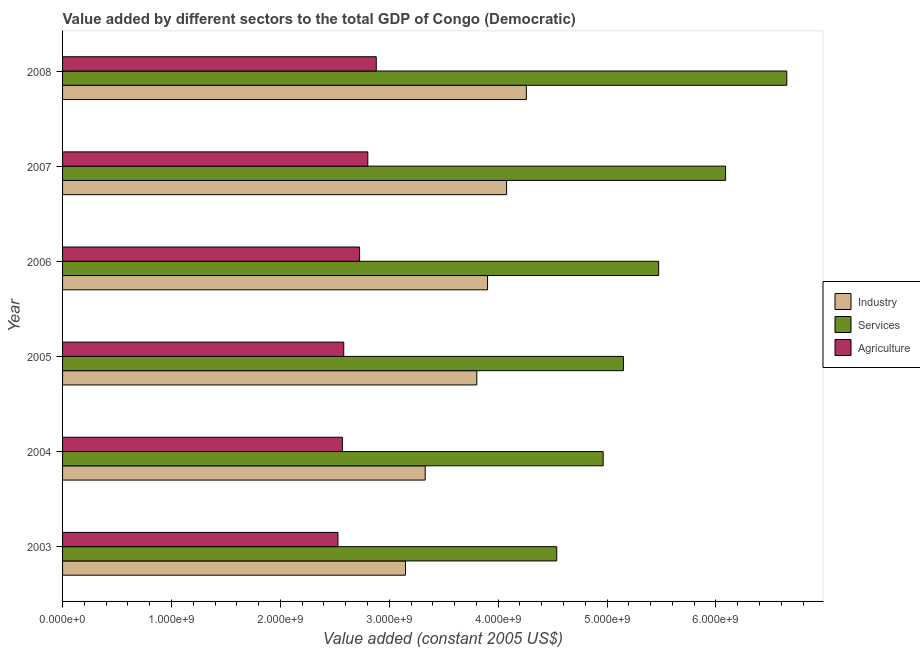Are the number of bars per tick equal to the number of legend labels?
Give a very brief answer. Yes. What is the label of the 4th group of bars from the top?
Provide a succinct answer. 2005. In how many cases, is the number of bars for a given year not equal to the number of legend labels?
Your response must be concise. 0. What is the value added by services in 2005?
Provide a succinct answer. 5.15e+09. Across all years, what is the maximum value added by services?
Provide a short and direct response. 6.65e+09. Across all years, what is the minimum value added by industrial sector?
Your answer should be very brief. 3.15e+09. In which year was the value added by agricultural sector maximum?
Make the answer very short. 2008. In which year was the value added by industrial sector minimum?
Offer a terse response. 2003. What is the total value added by services in the graph?
Offer a terse response. 3.29e+1. What is the difference between the value added by services in 2004 and that in 2007?
Your response must be concise. -1.12e+09. What is the difference between the value added by agricultural sector in 2008 and the value added by industrial sector in 2004?
Your answer should be compact. -4.49e+08. What is the average value added by industrial sector per year?
Your response must be concise. 3.75e+09. In the year 2005, what is the difference between the value added by services and value added by industrial sector?
Provide a short and direct response. 1.35e+09. What is the difference between the highest and the second highest value added by services?
Make the answer very short. 5.62e+08. What is the difference between the highest and the lowest value added by agricultural sector?
Offer a very short reply. 3.52e+08. What does the 3rd bar from the top in 2005 represents?
Your answer should be very brief. Industry. What does the 1st bar from the bottom in 2003 represents?
Give a very brief answer. Industry. Is it the case that in every year, the sum of the value added by industrial sector and value added by services is greater than the value added by agricultural sector?
Provide a short and direct response. Yes. How many years are there in the graph?
Your answer should be compact. 6. Does the graph contain any zero values?
Your answer should be very brief. No. Where does the legend appear in the graph?
Keep it short and to the point. Center right. What is the title of the graph?
Keep it short and to the point. Value added by different sectors to the total GDP of Congo (Democratic). Does "Secondary" appear as one of the legend labels in the graph?
Your answer should be compact. No. What is the label or title of the X-axis?
Offer a very short reply. Value added (constant 2005 US$). What is the label or title of the Y-axis?
Your response must be concise. Year. What is the Value added (constant 2005 US$) of Industry in 2003?
Give a very brief answer. 3.15e+09. What is the Value added (constant 2005 US$) of Services in 2003?
Offer a very short reply. 4.54e+09. What is the Value added (constant 2005 US$) in Agriculture in 2003?
Ensure brevity in your answer.  2.53e+09. What is the Value added (constant 2005 US$) of Industry in 2004?
Your answer should be very brief. 3.33e+09. What is the Value added (constant 2005 US$) in Services in 2004?
Offer a very short reply. 4.96e+09. What is the Value added (constant 2005 US$) in Agriculture in 2004?
Provide a succinct answer. 2.57e+09. What is the Value added (constant 2005 US$) of Industry in 2005?
Provide a short and direct response. 3.80e+09. What is the Value added (constant 2005 US$) in Services in 2005?
Your answer should be compact. 5.15e+09. What is the Value added (constant 2005 US$) of Agriculture in 2005?
Make the answer very short. 2.58e+09. What is the Value added (constant 2005 US$) of Industry in 2006?
Your response must be concise. 3.90e+09. What is the Value added (constant 2005 US$) of Services in 2006?
Offer a terse response. 5.47e+09. What is the Value added (constant 2005 US$) of Agriculture in 2006?
Ensure brevity in your answer.  2.73e+09. What is the Value added (constant 2005 US$) in Industry in 2007?
Ensure brevity in your answer.  4.08e+09. What is the Value added (constant 2005 US$) of Services in 2007?
Provide a short and direct response. 6.09e+09. What is the Value added (constant 2005 US$) of Agriculture in 2007?
Offer a terse response. 2.80e+09. What is the Value added (constant 2005 US$) in Industry in 2008?
Your answer should be compact. 4.26e+09. What is the Value added (constant 2005 US$) of Services in 2008?
Your answer should be very brief. 6.65e+09. What is the Value added (constant 2005 US$) of Agriculture in 2008?
Offer a very short reply. 2.88e+09. Across all years, what is the maximum Value added (constant 2005 US$) in Industry?
Keep it short and to the point. 4.26e+09. Across all years, what is the maximum Value added (constant 2005 US$) of Services?
Your answer should be compact. 6.65e+09. Across all years, what is the maximum Value added (constant 2005 US$) in Agriculture?
Your answer should be very brief. 2.88e+09. Across all years, what is the minimum Value added (constant 2005 US$) in Industry?
Your answer should be compact. 3.15e+09. Across all years, what is the minimum Value added (constant 2005 US$) in Services?
Ensure brevity in your answer.  4.54e+09. Across all years, what is the minimum Value added (constant 2005 US$) of Agriculture?
Make the answer very short. 2.53e+09. What is the total Value added (constant 2005 US$) of Industry in the graph?
Give a very brief answer. 2.25e+1. What is the total Value added (constant 2005 US$) of Services in the graph?
Your answer should be very brief. 3.29e+1. What is the total Value added (constant 2005 US$) in Agriculture in the graph?
Your answer should be compact. 1.61e+1. What is the difference between the Value added (constant 2005 US$) of Industry in 2003 and that in 2004?
Provide a succinct answer. -1.81e+08. What is the difference between the Value added (constant 2005 US$) of Services in 2003 and that in 2004?
Your response must be concise. -4.26e+08. What is the difference between the Value added (constant 2005 US$) of Agriculture in 2003 and that in 2004?
Give a very brief answer. -4.07e+07. What is the difference between the Value added (constant 2005 US$) in Industry in 2003 and that in 2005?
Provide a short and direct response. -6.55e+08. What is the difference between the Value added (constant 2005 US$) of Services in 2003 and that in 2005?
Provide a short and direct response. -6.12e+08. What is the difference between the Value added (constant 2005 US$) of Agriculture in 2003 and that in 2005?
Ensure brevity in your answer.  -5.32e+07. What is the difference between the Value added (constant 2005 US$) in Industry in 2003 and that in 2006?
Ensure brevity in your answer.  -7.54e+08. What is the difference between the Value added (constant 2005 US$) in Services in 2003 and that in 2006?
Ensure brevity in your answer.  -9.36e+08. What is the difference between the Value added (constant 2005 US$) of Agriculture in 2003 and that in 2006?
Offer a terse response. -1.99e+08. What is the difference between the Value added (constant 2005 US$) in Industry in 2003 and that in 2007?
Offer a terse response. -9.29e+08. What is the difference between the Value added (constant 2005 US$) in Services in 2003 and that in 2007?
Your answer should be compact. -1.55e+09. What is the difference between the Value added (constant 2005 US$) of Agriculture in 2003 and that in 2007?
Your response must be concise. -2.74e+08. What is the difference between the Value added (constant 2005 US$) of Industry in 2003 and that in 2008?
Give a very brief answer. -1.11e+09. What is the difference between the Value added (constant 2005 US$) of Services in 2003 and that in 2008?
Your answer should be compact. -2.11e+09. What is the difference between the Value added (constant 2005 US$) in Agriculture in 2003 and that in 2008?
Provide a succinct answer. -3.52e+08. What is the difference between the Value added (constant 2005 US$) of Industry in 2004 and that in 2005?
Offer a very short reply. -4.74e+08. What is the difference between the Value added (constant 2005 US$) of Services in 2004 and that in 2005?
Provide a short and direct response. -1.86e+08. What is the difference between the Value added (constant 2005 US$) in Agriculture in 2004 and that in 2005?
Your answer should be compact. -1.24e+07. What is the difference between the Value added (constant 2005 US$) in Industry in 2004 and that in 2006?
Give a very brief answer. -5.73e+08. What is the difference between the Value added (constant 2005 US$) of Services in 2004 and that in 2006?
Your answer should be compact. -5.10e+08. What is the difference between the Value added (constant 2005 US$) in Agriculture in 2004 and that in 2006?
Your answer should be compact. -1.58e+08. What is the difference between the Value added (constant 2005 US$) of Industry in 2004 and that in 2007?
Provide a succinct answer. -7.47e+08. What is the difference between the Value added (constant 2005 US$) of Services in 2004 and that in 2007?
Provide a short and direct response. -1.12e+09. What is the difference between the Value added (constant 2005 US$) in Agriculture in 2004 and that in 2007?
Provide a short and direct response. -2.33e+08. What is the difference between the Value added (constant 2005 US$) in Industry in 2004 and that in 2008?
Make the answer very short. -9.29e+08. What is the difference between the Value added (constant 2005 US$) in Services in 2004 and that in 2008?
Offer a terse response. -1.69e+09. What is the difference between the Value added (constant 2005 US$) in Agriculture in 2004 and that in 2008?
Your answer should be compact. -3.11e+08. What is the difference between the Value added (constant 2005 US$) of Industry in 2005 and that in 2006?
Your answer should be compact. -9.88e+07. What is the difference between the Value added (constant 2005 US$) of Services in 2005 and that in 2006?
Ensure brevity in your answer.  -3.24e+08. What is the difference between the Value added (constant 2005 US$) in Agriculture in 2005 and that in 2006?
Your answer should be compact. -1.45e+08. What is the difference between the Value added (constant 2005 US$) in Industry in 2005 and that in 2007?
Provide a short and direct response. -2.74e+08. What is the difference between the Value added (constant 2005 US$) of Services in 2005 and that in 2007?
Your answer should be very brief. -9.38e+08. What is the difference between the Value added (constant 2005 US$) of Agriculture in 2005 and that in 2007?
Keep it short and to the point. -2.21e+08. What is the difference between the Value added (constant 2005 US$) in Industry in 2005 and that in 2008?
Your answer should be compact. -4.55e+08. What is the difference between the Value added (constant 2005 US$) of Services in 2005 and that in 2008?
Keep it short and to the point. -1.50e+09. What is the difference between the Value added (constant 2005 US$) of Agriculture in 2005 and that in 2008?
Your response must be concise. -2.99e+08. What is the difference between the Value added (constant 2005 US$) in Industry in 2006 and that in 2007?
Your answer should be compact. -1.75e+08. What is the difference between the Value added (constant 2005 US$) in Services in 2006 and that in 2007?
Provide a short and direct response. -6.14e+08. What is the difference between the Value added (constant 2005 US$) of Agriculture in 2006 and that in 2007?
Offer a very short reply. -7.55e+07. What is the difference between the Value added (constant 2005 US$) of Industry in 2006 and that in 2008?
Your answer should be compact. -3.56e+08. What is the difference between the Value added (constant 2005 US$) in Services in 2006 and that in 2008?
Ensure brevity in your answer.  -1.18e+09. What is the difference between the Value added (constant 2005 US$) in Agriculture in 2006 and that in 2008?
Offer a very short reply. -1.53e+08. What is the difference between the Value added (constant 2005 US$) in Industry in 2007 and that in 2008?
Your response must be concise. -1.81e+08. What is the difference between the Value added (constant 2005 US$) of Services in 2007 and that in 2008?
Your response must be concise. -5.62e+08. What is the difference between the Value added (constant 2005 US$) of Agriculture in 2007 and that in 2008?
Offer a terse response. -7.77e+07. What is the difference between the Value added (constant 2005 US$) of Industry in 2003 and the Value added (constant 2005 US$) of Services in 2004?
Make the answer very short. -1.82e+09. What is the difference between the Value added (constant 2005 US$) of Industry in 2003 and the Value added (constant 2005 US$) of Agriculture in 2004?
Give a very brief answer. 5.79e+08. What is the difference between the Value added (constant 2005 US$) of Services in 2003 and the Value added (constant 2005 US$) of Agriculture in 2004?
Offer a terse response. 1.97e+09. What is the difference between the Value added (constant 2005 US$) of Industry in 2003 and the Value added (constant 2005 US$) of Services in 2005?
Your answer should be very brief. -2.00e+09. What is the difference between the Value added (constant 2005 US$) of Industry in 2003 and the Value added (constant 2005 US$) of Agriculture in 2005?
Your answer should be compact. 5.67e+08. What is the difference between the Value added (constant 2005 US$) in Services in 2003 and the Value added (constant 2005 US$) in Agriculture in 2005?
Your answer should be compact. 1.96e+09. What is the difference between the Value added (constant 2005 US$) in Industry in 2003 and the Value added (constant 2005 US$) in Services in 2006?
Offer a very short reply. -2.32e+09. What is the difference between the Value added (constant 2005 US$) of Industry in 2003 and the Value added (constant 2005 US$) of Agriculture in 2006?
Give a very brief answer. 4.22e+08. What is the difference between the Value added (constant 2005 US$) of Services in 2003 and the Value added (constant 2005 US$) of Agriculture in 2006?
Your answer should be very brief. 1.81e+09. What is the difference between the Value added (constant 2005 US$) in Industry in 2003 and the Value added (constant 2005 US$) in Services in 2007?
Ensure brevity in your answer.  -2.94e+09. What is the difference between the Value added (constant 2005 US$) in Industry in 2003 and the Value added (constant 2005 US$) in Agriculture in 2007?
Offer a very short reply. 3.46e+08. What is the difference between the Value added (constant 2005 US$) of Services in 2003 and the Value added (constant 2005 US$) of Agriculture in 2007?
Provide a succinct answer. 1.74e+09. What is the difference between the Value added (constant 2005 US$) of Industry in 2003 and the Value added (constant 2005 US$) of Services in 2008?
Make the answer very short. -3.50e+09. What is the difference between the Value added (constant 2005 US$) in Industry in 2003 and the Value added (constant 2005 US$) in Agriculture in 2008?
Offer a terse response. 2.68e+08. What is the difference between the Value added (constant 2005 US$) in Services in 2003 and the Value added (constant 2005 US$) in Agriculture in 2008?
Provide a short and direct response. 1.66e+09. What is the difference between the Value added (constant 2005 US$) of Industry in 2004 and the Value added (constant 2005 US$) of Services in 2005?
Offer a terse response. -1.82e+09. What is the difference between the Value added (constant 2005 US$) of Industry in 2004 and the Value added (constant 2005 US$) of Agriculture in 2005?
Provide a short and direct response. 7.48e+08. What is the difference between the Value added (constant 2005 US$) of Services in 2004 and the Value added (constant 2005 US$) of Agriculture in 2005?
Your answer should be compact. 2.38e+09. What is the difference between the Value added (constant 2005 US$) in Industry in 2004 and the Value added (constant 2005 US$) in Services in 2006?
Your response must be concise. -2.14e+09. What is the difference between the Value added (constant 2005 US$) of Industry in 2004 and the Value added (constant 2005 US$) of Agriculture in 2006?
Provide a succinct answer. 6.03e+08. What is the difference between the Value added (constant 2005 US$) of Services in 2004 and the Value added (constant 2005 US$) of Agriculture in 2006?
Your answer should be compact. 2.24e+09. What is the difference between the Value added (constant 2005 US$) in Industry in 2004 and the Value added (constant 2005 US$) in Services in 2007?
Your answer should be very brief. -2.76e+09. What is the difference between the Value added (constant 2005 US$) of Industry in 2004 and the Value added (constant 2005 US$) of Agriculture in 2007?
Your response must be concise. 5.27e+08. What is the difference between the Value added (constant 2005 US$) of Services in 2004 and the Value added (constant 2005 US$) of Agriculture in 2007?
Ensure brevity in your answer.  2.16e+09. What is the difference between the Value added (constant 2005 US$) in Industry in 2004 and the Value added (constant 2005 US$) in Services in 2008?
Your answer should be very brief. -3.32e+09. What is the difference between the Value added (constant 2005 US$) of Industry in 2004 and the Value added (constant 2005 US$) of Agriculture in 2008?
Your answer should be compact. 4.49e+08. What is the difference between the Value added (constant 2005 US$) of Services in 2004 and the Value added (constant 2005 US$) of Agriculture in 2008?
Your answer should be compact. 2.08e+09. What is the difference between the Value added (constant 2005 US$) of Industry in 2005 and the Value added (constant 2005 US$) of Services in 2006?
Provide a succinct answer. -1.67e+09. What is the difference between the Value added (constant 2005 US$) of Industry in 2005 and the Value added (constant 2005 US$) of Agriculture in 2006?
Make the answer very short. 1.08e+09. What is the difference between the Value added (constant 2005 US$) in Services in 2005 and the Value added (constant 2005 US$) in Agriculture in 2006?
Make the answer very short. 2.42e+09. What is the difference between the Value added (constant 2005 US$) of Industry in 2005 and the Value added (constant 2005 US$) of Services in 2007?
Provide a short and direct response. -2.28e+09. What is the difference between the Value added (constant 2005 US$) in Industry in 2005 and the Value added (constant 2005 US$) in Agriculture in 2007?
Give a very brief answer. 1.00e+09. What is the difference between the Value added (constant 2005 US$) in Services in 2005 and the Value added (constant 2005 US$) in Agriculture in 2007?
Keep it short and to the point. 2.35e+09. What is the difference between the Value added (constant 2005 US$) of Industry in 2005 and the Value added (constant 2005 US$) of Services in 2008?
Give a very brief answer. -2.85e+09. What is the difference between the Value added (constant 2005 US$) in Industry in 2005 and the Value added (constant 2005 US$) in Agriculture in 2008?
Your answer should be very brief. 9.23e+08. What is the difference between the Value added (constant 2005 US$) in Services in 2005 and the Value added (constant 2005 US$) in Agriculture in 2008?
Provide a short and direct response. 2.27e+09. What is the difference between the Value added (constant 2005 US$) in Industry in 2006 and the Value added (constant 2005 US$) in Services in 2007?
Provide a succinct answer. -2.19e+09. What is the difference between the Value added (constant 2005 US$) in Industry in 2006 and the Value added (constant 2005 US$) in Agriculture in 2007?
Give a very brief answer. 1.10e+09. What is the difference between the Value added (constant 2005 US$) in Services in 2006 and the Value added (constant 2005 US$) in Agriculture in 2007?
Offer a very short reply. 2.67e+09. What is the difference between the Value added (constant 2005 US$) in Industry in 2006 and the Value added (constant 2005 US$) in Services in 2008?
Your response must be concise. -2.75e+09. What is the difference between the Value added (constant 2005 US$) of Industry in 2006 and the Value added (constant 2005 US$) of Agriculture in 2008?
Provide a short and direct response. 1.02e+09. What is the difference between the Value added (constant 2005 US$) in Services in 2006 and the Value added (constant 2005 US$) in Agriculture in 2008?
Offer a very short reply. 2.59e+09. What is the difference between the Value added (constant 2005 US$) of Industry in 2007 and the Value added (constant 2005 US$) of Services in 2008?
Your response must be concise. -2.57e+09. What is the difference between the Value added (constant 2005 US$) in Industry in 2007 and the Value added (constant 2005 US$) in Agriculture in 2008?
Your answer should be very brief. 1.20e+09. What is the difference between the Value added (constant 2005 US$) in Services in 2007 and the Value added (constant 2005 US$) in Agriculture in 2008?
Your response must be concise. 3.21e+09. What is the average Value added (constant 2005 US$) in Industry per year?
Make the answer very short. 3.75e+09. What is the average Value added (constant 2005 US$) of Services per year?
Your answer should be very brief. 5.48e+09. What is the average Value added (constant 2005 US$) in Agriculture per year?
Keep it short and to the point. 2.68e+09. In the year 2003, what is the difference between the Value added (constant 2005 US$) in Industry and Value added (constant 2005 US$) in Services?
Your answer should be very brief. -1.39e+09. In the year 2003, what is the difference between the Value added (constant 2005 US$) in Industry and Value added (constant 2005 US$) in Agriculture?
Provide a short and direct response. 6.20e+08. In the year 2003, what is the difference between the Value added (constant 2005 US$) of Services and Value added (constant 2005 US$) of Agriculture?
Keep it short and to the point. 2.01e+09. In the year 2004, what is the difference between the Value added (constant 2005 US$) in Industry and Value added (constant 2005 US$) in Services?
Offer a very short reply. -1.63e+09. In the year 2004, what is the difference between the Value added (constant 2005 US$) of Industry and Value added (constant 2005 US$) of Agriculture?
Provide a succinct answer. 7.60e+08. In the year 2004, what is the difference between the Value added (constant 2005 US$) of Services and Value added (constant 2005 US$) of Agriculture?
Your response must be concise. 2.39e+09. In the year 2005, what is the difference between the Value added (constant 2005 US$) in Industry and Value added (constant 2005 US$) in Services?
Provide a short and direct response. -1.35e+09. In the year 2005, what is the difference between the Value added (constant 2005 US$) in Industry and Value added (constant 2005 US$) in Agriculture?
Provide a succinct answer. 1.22e+09. In the year 2005, what is the difference between the Value added (constant 2005 US$) in Services and Value added (constant 2005 US$) in Agriculture?
Your answer should be very brief. 2.57e+09. In the year 2006, what is the difference between the Value added (constant 2005 US$) in Industry and Value added (constant 2005 US$) in Services?
Your response must be concise. -1.57e+09. In the year 2006, what is the difference between the Value added (constant 2005 US$) of Industry and Value added (constant 2005 US$) of Agriculture?
Make the answer very short. 1.18e+09. In the year 2006, what is the difference between the Value added (constant 2005 US$) in Services and Value added (constant 2005 US$) in Agriculture?
Offer a terse response. 2.75e+09. In the year 2007, what is the difference between the Value added (constant 2005 US$) in Industry and Value added (constant 2005 US$) in Services?
Ensure brevity in your answer.  -2.01e+09. In the year 2007, what is the difference between the Value added (constant 2005 US$) of Industry and Value added (constant 2005 US$) of Agriculture?
Give a very brief answer. 1.27e+09. In the year 2007, what is the difference between the Value added (constant 2005 US$) of Services and Value added (constant 2005 US$) of Agriculture?
Provide a short and direct response. 3.29e+09. In the year 2008, what is the difference between the Value added (constant 2005 US$) in Industry and Value added (constant 2005 US$) in Services?
Your answer should be very brief. -2.39e+09. In the year 2008, what is the difference between the Value added (constant 2005 US$) of Industry and Value added (constant 2005 US$) of Agriculture?
Offer a very short reply. 1.38e+09. In the year 2008, what is the difference between the Value added (constant 2005 US$) in Services and Value added (constant 2005 US$) in Agriculture?
Make the answer very short. 3.77e+09. What is the ratio of the Value added (constant 2005 US$) of Industry in 2003 to that in 2004?
Make the answer very short. 0.95. What is the ratio of the Value added (constant 2005 US$) of Services in 2003 to that in 2004?
Your answer should be very brief. 0.91. What is the ratio of the Value added (constant 2005 US$) in Agriculture in 2003 to that in 2004?
Keep it short and to the point. 0.98. What is the ratio of the Value added (constant 2005 US$) of Industry in 2003 to that in 2005?
Make the answer very short. 0.83. What is the ratio of the Value added (constant 2005 US$) of Services in 2003 to that in 2005?
Your response must be concise. 0.88. What is the ratio of the Value added (constant 2005 US$) of Agriculture in 2003 to that in 2005?
Ensure brevity in your answer.  0.98. What is the ratio of the Value added (constant 2005 US$) in Industry in 2003 to that in 2006?
Give a very brief answer. 0.81. What is the ratio of the Value added (constant 2005 US$) of Services in 2003 to that in 2006?
Your answer should be compact. 0.83. What is the ratio of the Value added (constant 2005 US$) of Agriculture in 2003 to that in 2006?
Make the answer very short. 0.93. What is the ratio of the Value added (constant 2005 US$) of Industry in 2003 to that in 2007?
Offer a terse response. 0.77. What is the ratio of the Value added (constant 2005 US$) in Services in 2003 to that in 2007?
Your answer should be compact. 0.75. What is the ratio of the Value added (constant 2005 US$) in Agriculture in 2003 to that in 2007?
Your answer should be compact. 0.9. What is the ratio of the Value added (constant 2005 US$) in Industry in 2003 to that in 2008?
Ensure brevity in your answer.  0.74. What is the ratio of the Value added (constant 2005 US$) of Services in 2003 to that in 2008?
Provide a succinct answer. 0.68. What is the ratio of the Value added (constant 2005 US$) of Agriculture in 2003 to that in 2008?
Provide a short and direct response. 0.88. What is the ratio of the Value added (constant 2005 US$) in Industry in 2004 to that in 2005?
Make the answer very short. 0.88. What is the ratio of the Value added (constant 2005 US$) in Services in 2004 to that in 2005?
Ensure brevity in your answer.  0.96. What is the ratio of the Value added (constant 2005 US$) in Industry in 2004 to that in 2006?
Your response must be concise. 0.85. What is the ratio of the Value added (constant 2005 US$) of Services in 2004 to that in 2006?
Keep it short and to the point. 0.91. What is the ratio of the Value added (constant 2005 US$) of Agriculture in 2004 to that in 2006?
Keep it short and to the point. 0.94. What is the ratio of the Value added (constant 2005 US$) in Industry in 2004 to that in 2007?
Offer a terse response. 0.82. What is the ratio of the Value added (constant 2005 US$) of Services in 2004 to that in 2007?
Provide a short and direct response. 0.82. What is the ratio of the Value added (constant 2005 US$) in Agriculture in 2004 to that in 2007?
Your answer should be very brief. 0.92. What is the ratio of the Value added (constant 2005 US$) of Industry in 2004 to that in 2008?
Provide a succinct answer. 0.78. What is the ratio of the Value added (constant 2005 US$) in Services in 2004 to that in 2008?
Keep it short and to the point. 0.75. What is the ratio of the Value added (constant 2005 US$) in Agriculture in 2004 to that in 2008?
Give a very brief answer. 0.89. What is the ratio of the Value added (constant 2005 US$) of Industry in 2005 to that in 2006?
Your answer should be very brief. 0.97. What is the ratio of the Value added (constant 2005 US$) of Services in 2005 to that in 2006?
Ensure brevity in your answer.  0.94. What is the ratio of the Value added (constant 2005 US$) of Agriculture in 2005 to that in 2006?
Ensure brevity in your answer.  0.95. What is the ratio of the Value added (constant 2005 US$) of Industry in 2005 to that in 2007?
Provide a short and direct response. 0.93. What is the ratio of the Value added (constant 2005 US$) in Services in 2005 to that in 2007?
Offer a terse response. 0.85. What is the ratio of the Value added (constant 2005 US$) of Agriculture in 2005 to that in 2007?
Your answer should be compact. 0.92. What is the ratio of the Value added (constant 2005 US$) in Industry in 2005 to that in 2008?
Make the answer very short. 0.89. What is the ratio of the Value added (constant 2005 US$) in Services in 2005 to that in 2008?
Your response must be concise. 0.77. What is the ratio of the Value added (constant 2005 US$) of Agriculture in 2005 to that in 2008?
Offer a terse response. 0.9. What is the ratio of the Value added (constant 2005 US$) of Industry in 2006 to that in 2007?
Ensure brevity in your answer.  0.96. What is the ratio of the Value added (constant 2005 US$) in Services in 2006 to that in 2007?
Your answer should be compact. 0.9. What is the ratio of the Value added (constant 2005 US$) of Agriculture in 2006 to that in 2007?
Offer a very short reply. 0.97. What is the ratio of the Value added (constant 2005 US$) of Industry in 2006 to that in 2008?
Give a very brief answer. 0.92. What is the ratio of the Value added (constant 2005 US$) of Services in 2006 to that in 2008?
Make the answer very short. 0.82. What is the ratio of the Value added (constant 2005 US$) of Agriculture in 2006 to that in 2008?
Offer a terse response. 0.95. What is the ratio of the Value added (constant 2005 US$) in Industry in 2007 to that in 2008?
Provide a short and direct response. 0.96. What is the ratio of the Value added (constant 2005 US$) of Services in 2007 to that in 2008?
Your answer should be very brief. 0.92. What is the difference between the highest and the second highest Value added (constant 2005 US$) in Industry?
Keep it short and to the point. 1.81e+08. What is the difference between the highest and the second highest Value added (constant 2005 US$) in Services?
Ensure brevity in your answer.  5.62e+08. What is the difference between the highest and the second highest Value added (constant 2005 US$) in Agriculture?
Give a very brief answer. 7.77e+07. What is the difference between the highest and the lowest Value added (constant 2005 US$) of Industry?
Provide a succinct answer. 1.11e+09. What is the difference between the highest and the lowest Value added (constant 2005 US$) of Services?
Offer a very short reply. 2.11e+09. What is the difference between the highest and the lowest Value added (constant 2005 US$) of Agriculture?
Your answer should be very brief. 3.52e+08. 